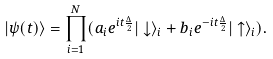<formula> <loc_0><loc_0><loc_500><loc_500>| \psi ( t ) \rangle = \prod _ { i = 1 } ^ { N } ( a _ { i } e ^ { i t \frac { \Delta } { 2 } } | \downarrow \rangle _ { i } + b _ { i } e ^ { - i t \frac { \Delta } { 2 } } | \uparrow \rangle _ { i } ) .</formula> 